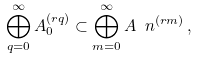Convert formula to latex. <formula><loc_0><loc_0><loc_500><loc_500>\bigoplus _ { q = 0 } ^ { \infty } A _ { 0 } ^ { ( r q ) } \subset \bigoplus _ { m = 0 } ^ { \infty } A _ { \ } n ^ { ( r m ) } \, ,</formula> 